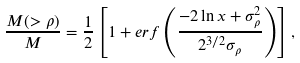Convert formula to latex. <formula><loc_0><loc_0><loc_500><loc_500>\frac { M ( > \rho ) } { M } = \frac { 1 } { 2 } \left [ 1 + e r f \left ( \frac { - 2 \ln x + \sigma _ { \rho } ^ { 2 } } { 2 ^ { 3 / 2 } \sigma _ { \rho } } \right ) \right ] ,</formula> 